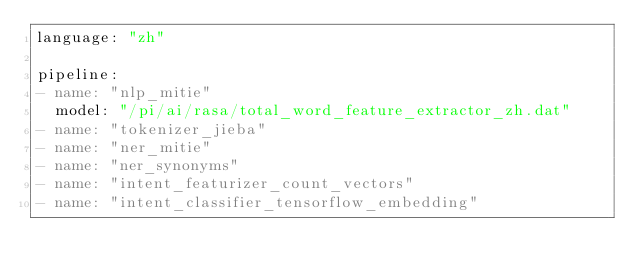<code> <loc_0><loc_0><loc_500><loc_500><_YAML_>language: "zh"

pipeline:
- name: "nlp_mitie"
  model: "/pi/ai/rasa/total_word_feature_extractor_zh.dat"
- name: "tokenizer_jieba"
- name: "ner_mitie"
- name: "ner_synonyms"
- name: "intent_featurizer_count_vectors"
- name: "intent_classifier_tensorflow_embedding"

</code> 